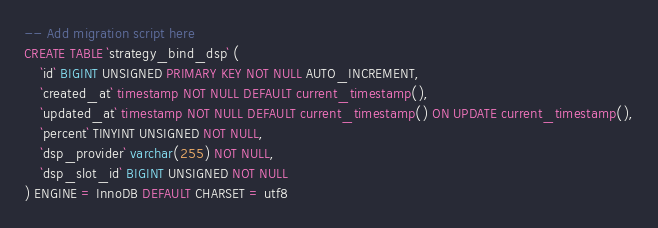<code> <loc_0><loc_0><loc_500><loc_500><_SQL_>-- Add migration script here
CREATE TABLE `strategy_bind_dsp` (
	`id` BIGINT UNSIGNED PRIMARY KEY NOT NULL AUTO_INCREMENT,
	`created_at` timestamp NOT NULL DEFAULT current_timestamp(),
	`updated_at` timestamp NOT NULL DEFAULT current_timestamp() ON UPDATE current_timestamp(),
	`percent` TINYINT UNSIGNED NOT NULL,
	`dsp_provider` varchar(255) NOT NULL,
	`dsp_slot_id` BIGINT UNSIGNED NOT NULL
) ENGINE = InnoDB DEFAULT CHARSET = utf8</code> 